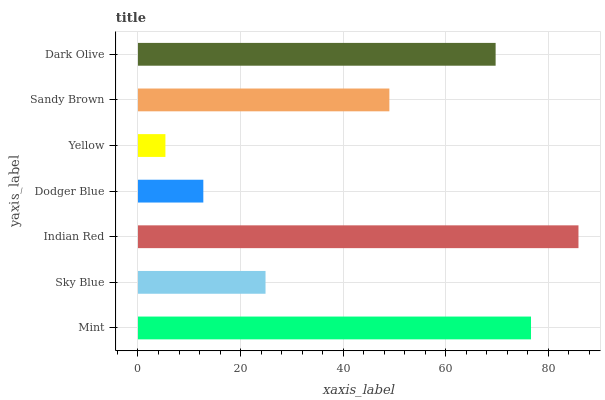Is Yellow the minimum?
Answer yes or no. Yes. Is Indian Red the maximum?
Answer yes or no. Yes. Is Sky Blue the minimum?
Answer yes or no. No. Is Sky Blue the maximum?
Answer yes or no. No. Is Mint greater than Sky Blue?
Answer yes or no. Yes. Is Sky Blue less than Mint?
Answer yes or no. Yes. Is Sky Blue greater than Mint?
Answer yes or no. No. Is Mint less than Sky Blue?
Answer yes or no. No. Is Sandy Brown the high median?
Answer yes or no. Yes. Is Sandy Brown the low median?
Answer yes or no. Yes. Is Mint the high median?
Answer yes or no. No. Is Sky Blue the low median?
Answer yes or no. No. 